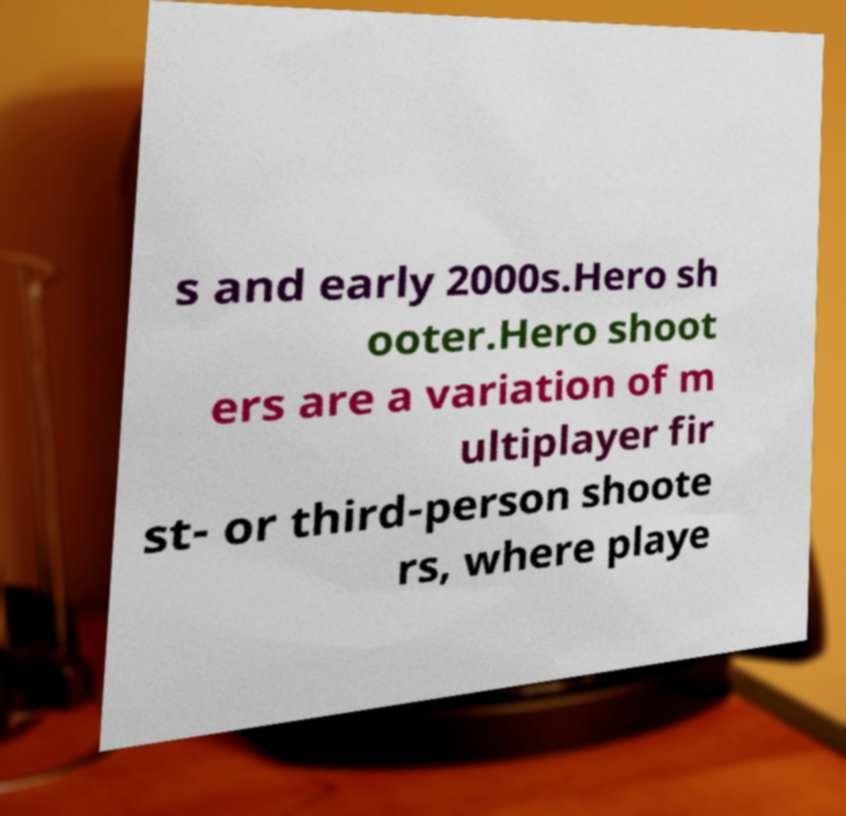Could you extract and type out the text from this image? s and early 2000s.Hero sh ooter.Hero shoot ers are a variation of m ultiplayer fir st- or third-person shoote rs, where playe 